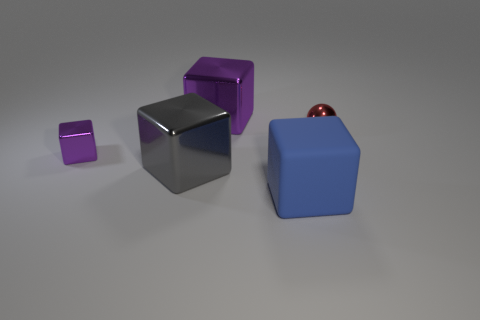What number of other things are the same color as the small block?
Make the answer very short. 1. What size is the metallic object that is on the right side of the gray shiny block and to the left of the big blue rubber block?
Ensure brevity in your answer.  Large. There is a small thing that is on the right side of the purple thing behind the red sphere; what is its color?
Your answer should be very brief. Red. What number of gray things are either tiny cubes or metallic spheres?
Your response must be concise. 0. The large cube that is both in front of the tiny red ball and behind the matte object is what color?
Your response must be concise. Gray. How many large things are gray things or metal balls?
Give a very brief answer. 1. There is a gray object that is the same shape as the large blue thing; what size is it?
Give a very brief answer. Large. There is a blue thing; what shape is it?
Your answer should be very brief. Cube. Are the big gray block and the purple cube that is behind the red thing made of the same material?
Your answer should be very brief. Yes. How many matte things are tiny balls or large red balls?
Provide a short and direct response. 0. 